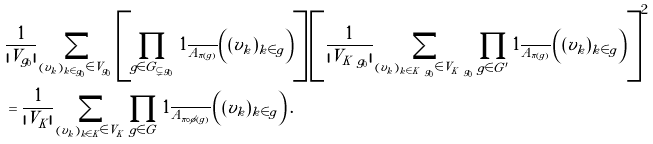<formula> <loc_0><loc_0><loc_500><loc_500>& \frac { 1 } { | V _ { g _ { 0 } } | } \sum _ { ( v _ { k } ) _ { k \in g _ { 0 } } \in V _ { g _ { 0 } } } \left [ \prod _ { g \in G _ { \subsetneq g _ { 0 } } } 1 _ { \overline { A _ { \pi ( g ) } } } \left ( ( v _ { k } ) _ { k \in g } \right ) \right ] \left [ \frac { 1 } { | V _ { K \ g _ { 0 } } | } \sum _ { ( v _ { k } ) _ { k \in K \ g _ { 0 } } \in V _ { K \ g _ { 0 } } } \prod _ { g \in G ^ { \prime } } 1 _ { \overline { A _ { \pi ( g ) } } } \left ( ( v _ { k } ) _ { k \in g } \right ) \right ] ^ { 2 } \\ & = \frac { 1 } { | V _ { \tilde { K } } | } \sum _ { ( v _ { \tilde { k } } ) _ { \tilde { k } \in \tilde { K } } \in V _ { \tilde { K } } } \prod _ { \tilde { g } \in \tilde { G } } 1 _ { \overline { A _ { \pi \circ \phi ( \tilde { g } ) } } } \left ( ( v _ { \tilde { k } } ) _ { \tilde { k } \in \tilde { g } } \right ) .</formula> 